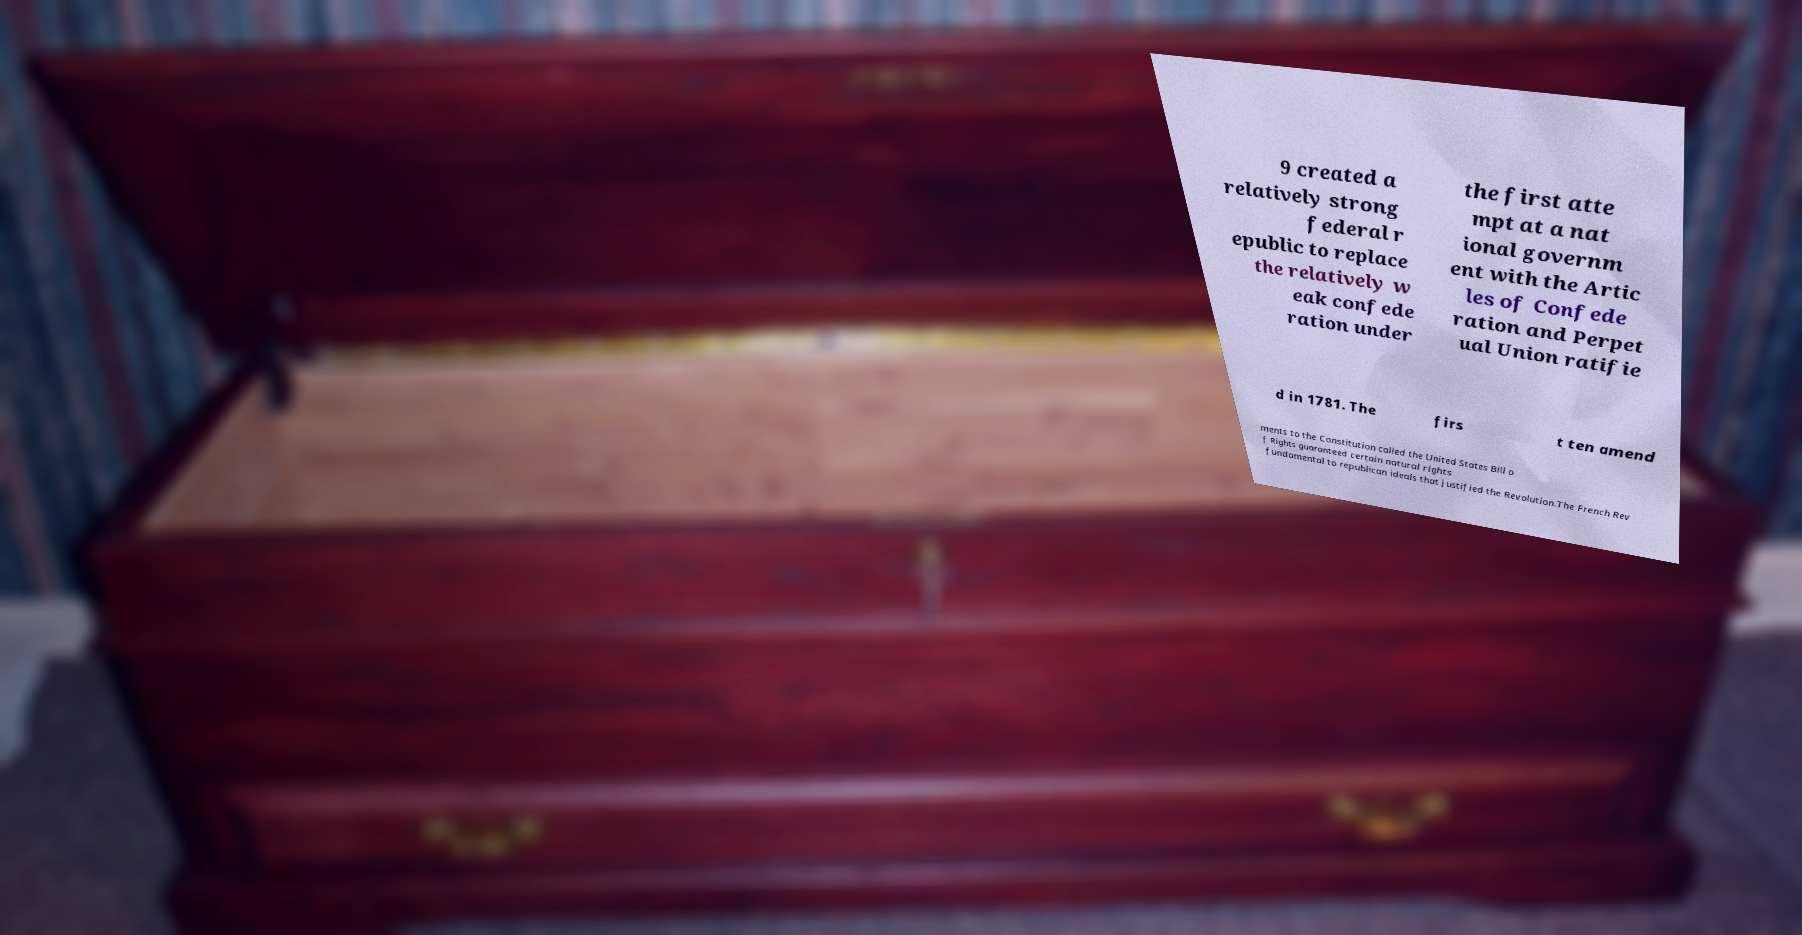Can you read and provide the text displayed in the image?This photo seems to have some interesting text. Can you extract and type it out for me? 9 created a relatively strong federal r epublic to replace the relatively w eak confede ration under the first atte mpt at a nat ional governm ent with the Artic les of Confede ration and Perpet ual Union ratifie d in 1781. The firs t ten amend ments to the Constitution called the United States Bill o f Rights guaranteed certain natural rights fundamental to republican ideals that justified the Revolution.The French Rev 